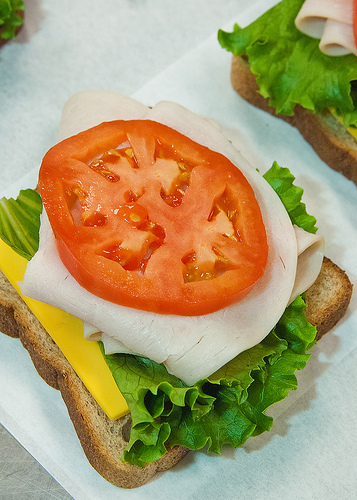<image>
Is there a cheese on the lettuce? No. The cheese is not positioned on the lettuce. They may be near each other, but the cheese is not supported by or resting on top of the lettuce. Is the cheese under the lettuce? Yes. The cheese is positioned underneath the lettuce, with the lettuce above it in the vertical space. Is the tomato above the bread? Yes. The tomato is positioned above the bread in the vertical space, higher up in the scene. 